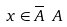Convert formula to latex. <formula><loc_0><loc_0><loc_500><loc_500>x \in \overline { A } \ A</formula> 